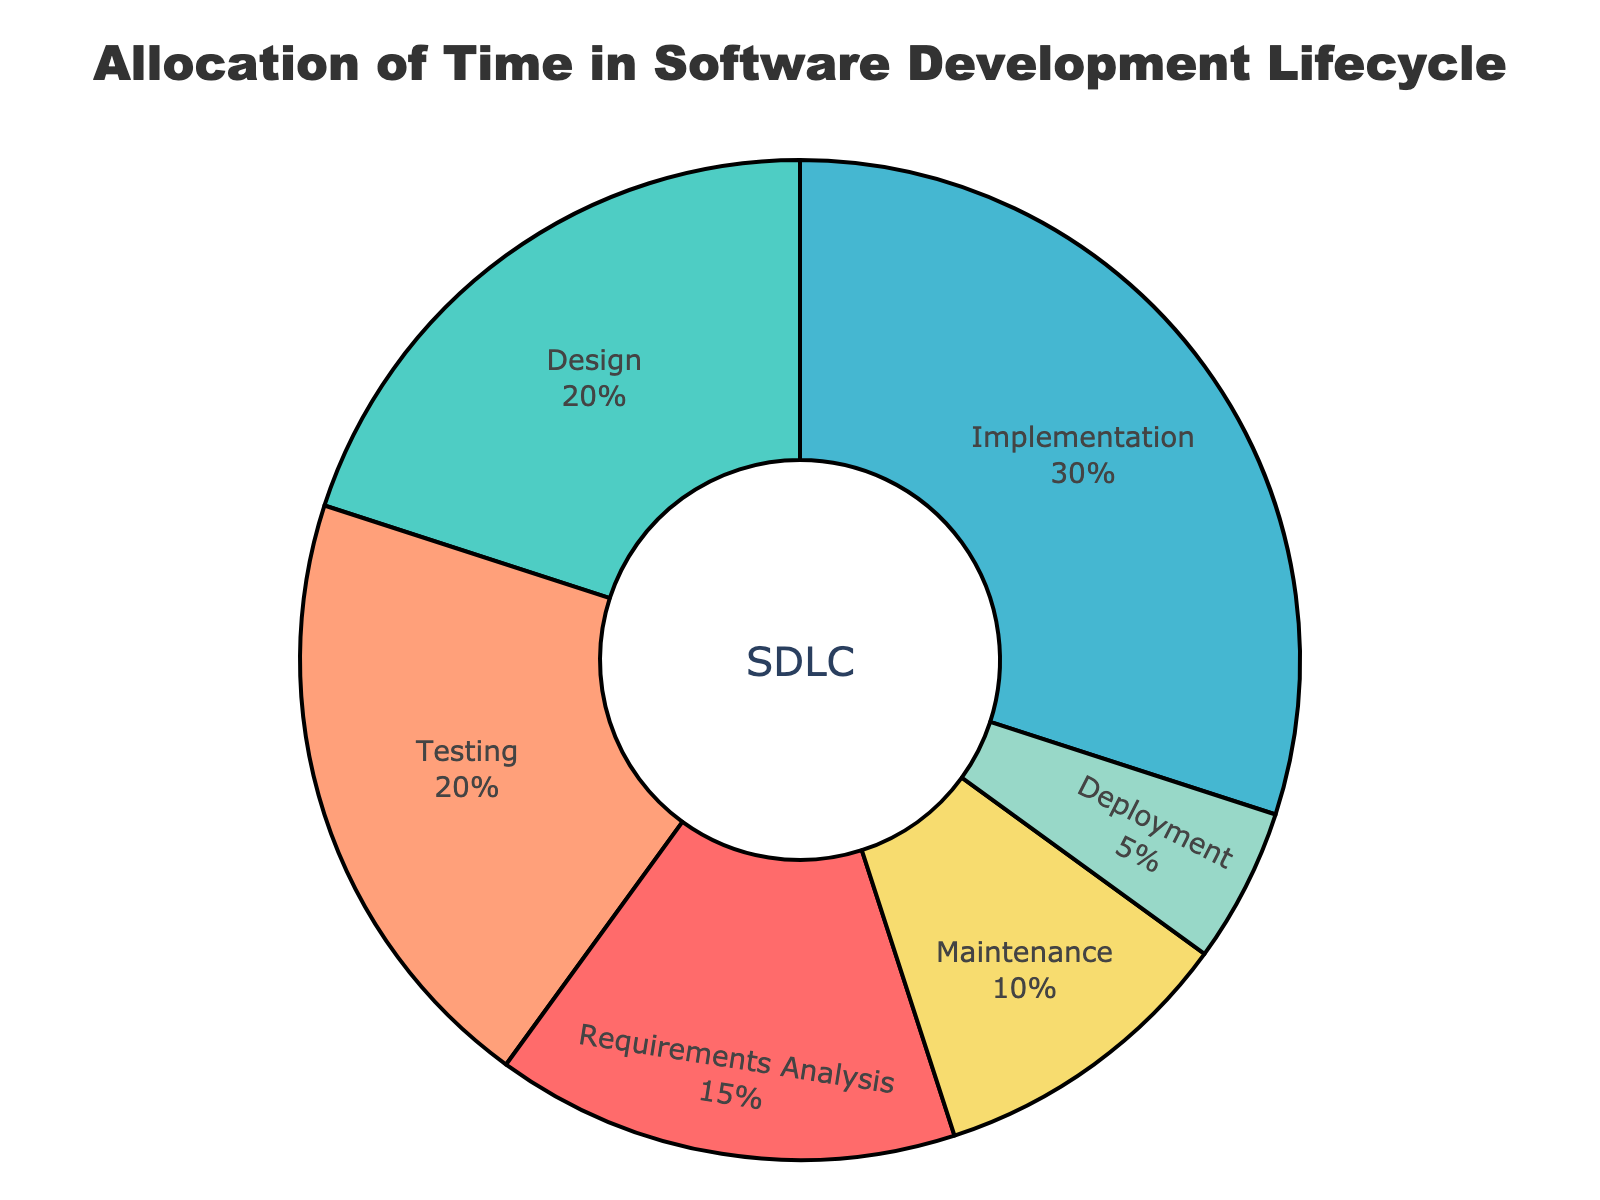Which phase takes the highest percentage of time? The phase with the highest percentage of time can be identified by comparing all the percentages in the chart. Implementation has 30%, which is higher than any other phase.
Answer: Implementation How much more time is spent on Implementation compared to Deployment? First, identify the percentages for Implementation (30%) and Deployment (5%). Then, subtract the Deployment percentage from the Implementation percentage: 30% - 5% = 25%.
Answer: 25% Which two phases combined account for the same percentage as the Implementation phase? Implementation takes 30%. Find two phases whose percentages sum to 30%. Requirements Analysis (15%) and Maintenance (10%) together make 25%, but Design (20%) and Testing (20%) sum to 40%. The correct pair is Design (20%) and Maintenance (10%): 20% + 10% = 30%.
Answer: Design and Maintenance What is the total percentage of time spent on Design and Testing combined? Look at the percentages for Design (20%) and Testing (20%). Add them together: 20% + 20% = 40%.
Answer: 40% If the total time is 100 hours, how many hours are allocated to Maintenance? Given that Maintenance is allocated 10% of the total time, convert this percentage to hours: 10% of 100 hours = 10 hours.
Answer: 10 hours Which phase takes the least amount of time, and what is its percentage? The phase with the smallest percentage can be found by comparing all percentages. Deployment has 5%, which is the smallest.
Answer: Deployment, 5% How much more time is spent on Testing compared to Maintenance? Identify the percentages for Testing (20%) and Maintenance (10%). Subtract the Maintenance percentage from the Testing percentage: 20% - 10% = 10%.
Answer: 10% Compare the time spent on Requirements Analysis and Maintenance combined to that of Testing. Which is greater and by how much? Requirements Analysis is 15%, and Maintenance is 10%. Combined, they are 15% + 10% = 25%. Testing is 20%. The combined time for Requirements Analysis and Maintenance (25%) is greater than Testing (20%) by 25% - 20% = 5%.
Answer: Combined time is greater by 5% If we reduce the time allocated for Implementation by 10%, how would that affect the percentage allocation for Deployment? Reducing Implementation by 10% changes it from 30% to 27%. Deployment remains at 5%, so the total is now 95%. The adjusted percentage for Deployment in a new total (95%) is (5/95) * 100% = approximately 5.26%.
Answer: Approximately 5.26% What percentage of time is spent on phases other than Implementation? Implementation alone takes 30%. Subtract this from 100% to find out the percentage spent on other phases: 100% - 30% = 70%.
Answer: 70% 